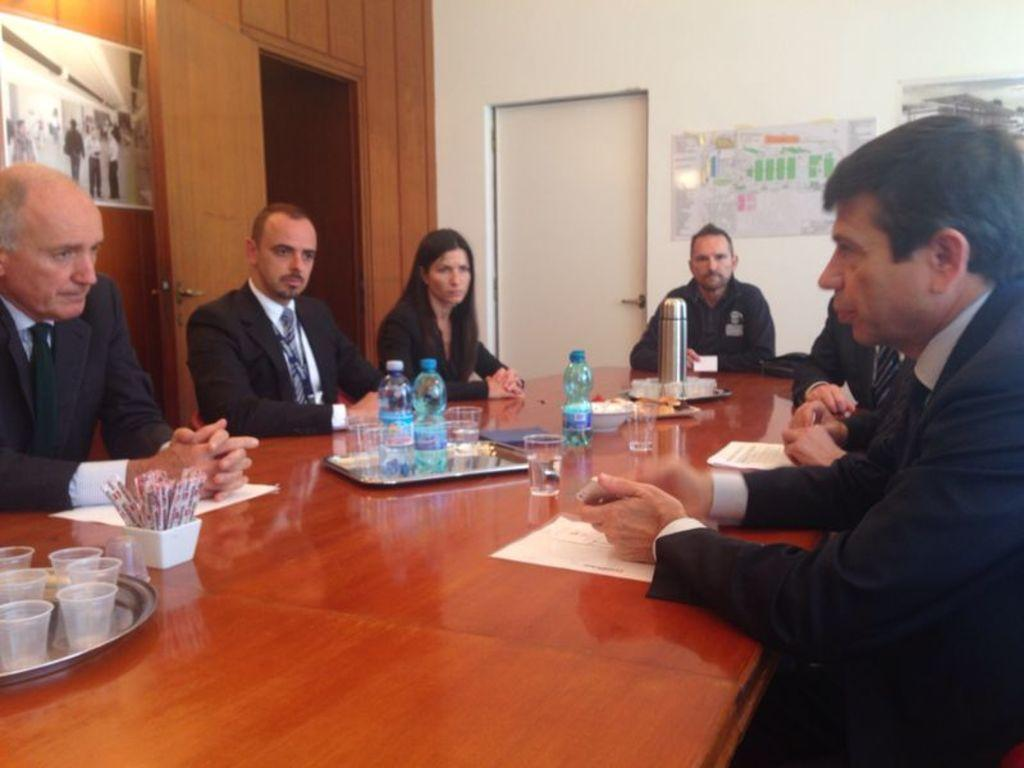What are the people in the image doing? There is a group of people sitting in the image. What is in front of the group of people? There is a table in front of the group of people. What can be seen on the table? There are water bottles, a flask, sugar packets, and glasses on the table. What word is written on the back of the flask in the image? There is no word written on the back of the flask in the image, as the flask is not shown from the back. 